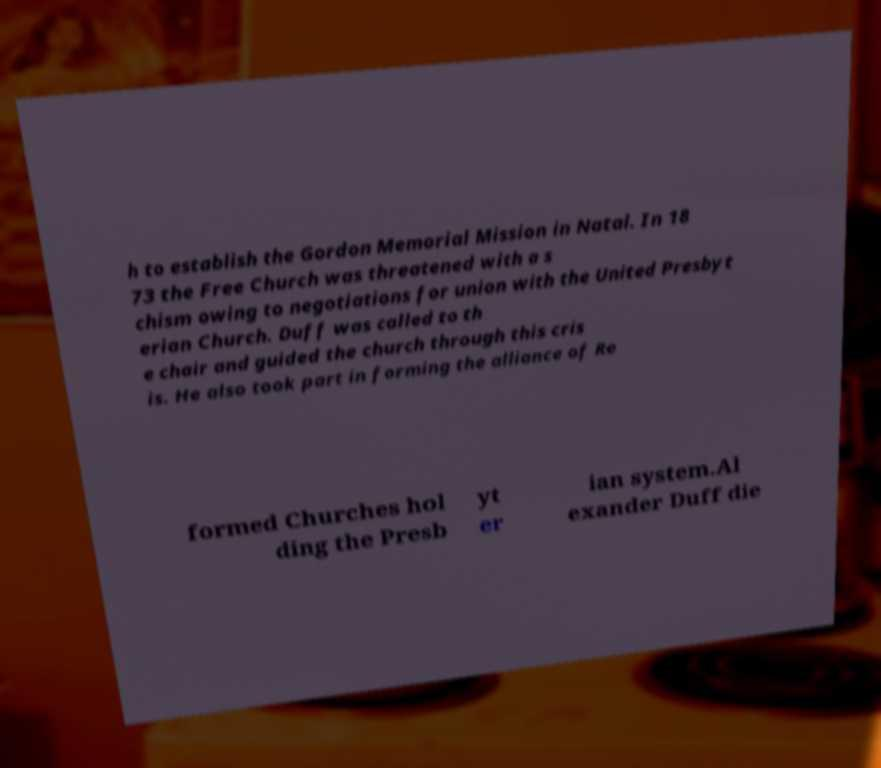Can you read and provide the text displayed in the image?This photo seems to have some interesting text. Can you extract and type it out for me? h to establish the Gordon Memorial Mission in Natal. In 18 73 the Free Church was threatened with a s chism owing to negotiations for union with the United Presbyt erian Church. Duff was called to th e chair and guided the church through this cris is. He also took part in forming the alliance of Re formed Churches hol ding the Presb yt er ian system.Al exander Duff die 